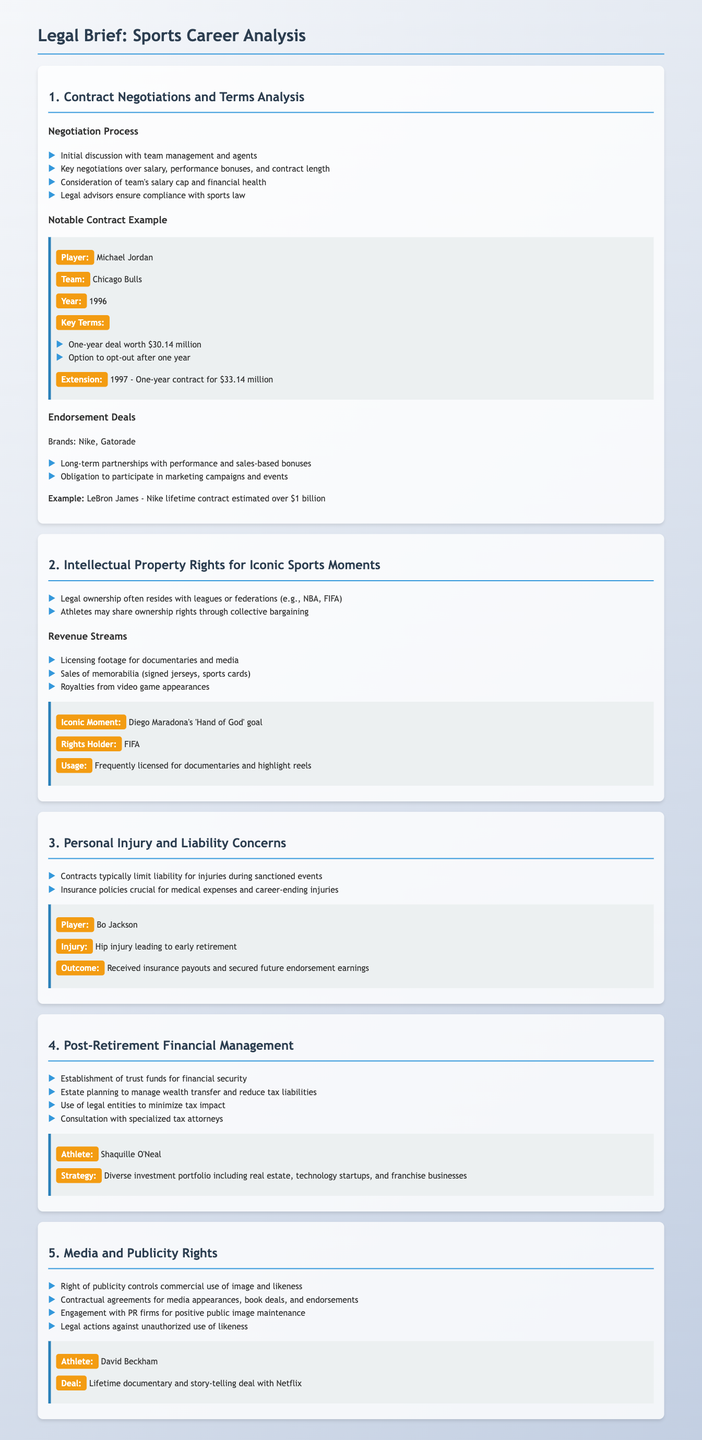what was the contract value for Michael Jordan in 1996? The document states that Michael Jordan signed a one-year deal worth $30.14 million in 1996.
Answer: $30.14 million who is the rights holder for Diego Maradona's iconic moment? According to the document, FIFA is the rights holder for Diego Maradona's 'Hand of God' goal.
Answer: FIFA what injury did Bo Jackson suffer leading to early retirement? The document specifies that Bo Jackson suffered a hip injury that led to his early retirement.
Answer: hip injury what overall financial strategy does Shaquille O'Neal employ post-retirement? The document notes that Shaquille O'Neal has a diverse investment portfolio including real estate, technology startups, and franchise businesses.
Answer: diverse investment portfolio who has a lifetime documentary deal with Netflix? According to the document, David Beckham has a lifetime documentary and story-telling deal with Netflix.
Answer: David Beckham what is the estimated value of LeBron James's Nike lifetime contract? The document states that LeBron James's lifetime contract with Nike is estimated to be over $1 billion.
Answer: over $1 billion what type of event typically limits liability for injuries? The document mentions that contracts typically limit liability for injuries during sanctioned events.
Answer: sanctioned events in what year was Michael Jordan's contract extended? The document states that Michael Jordan's contract was extended in 1997.
Answer: 1997 what are athletes obligated to do under endorsement deals? The document notes that athletes are obligated to participate in marketing campaigns and events as part of their endorsement deals.
Answer: participate in marketing campaigns and events 